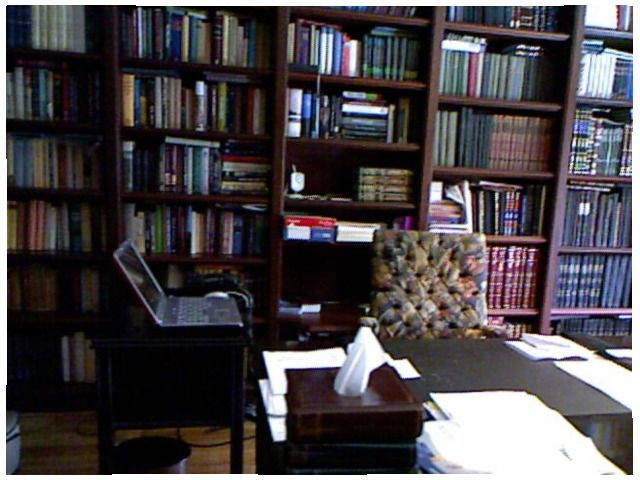<image>
Is the table under the paper? Yes. The table is positioned underneath the paper, with the paper above it in the vertical space. Is there a books on the shelf? Yes. Looking at the image, I can see the books is positioned on top of the shelf, with the shelf providing support. Is the books on the rack self? Yes. Looking at the image, I can see the books is positioned on top of the rack self, with the rack self providing support. Is the laptop on the table? No. The laptop is not positioned on the table. They may be near each other, but the laptop is not supported by or resting on top of the table. 